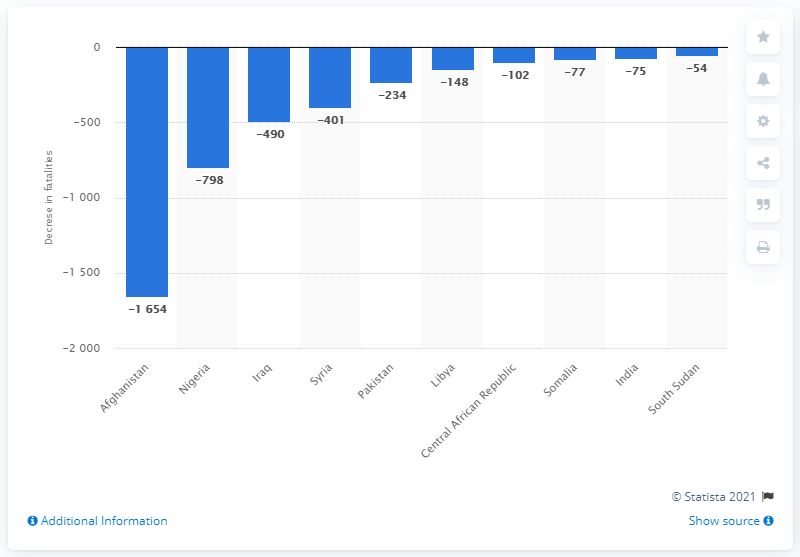Give some essential details in this illustration. Afghanistan experienced the largest decrease in deaths from terrorism in 2019, compared to the previous year. Nigeria experienced 798 fewer deaths due to terrorism in 2019 compared to 2018, making it the country with the largest reduction in terrorism-related fatalities that year. 